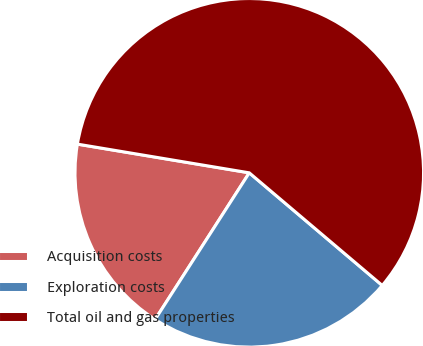Convert chart. <chart><loc_0><loc_0><loc_500><loc_500><pie_chart><fcel>Acquisition costs<fcel>Exploration costs<fcel>Total oil and gas properties<nl><fcel>18.55%<fcel>22.9%<fcel>58.55%<nl></chart> 